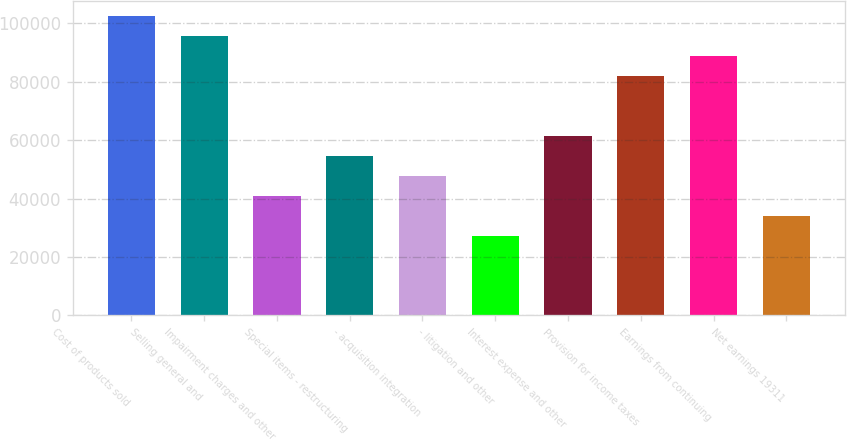<chart> <loc_0><loc_0><loc_500><loc_500><bar_chart><fcel>Cost of products sold<fcel>Selling general and<fcel>Impairment charges and other<fcel>Special items - restructuring<fcel>- acquisition integration<fcel>- litigation and other<fcel>Interest expense and other<fcel>Provision for income taxes<fcel>Earnings from continuing<fcel>Net earnings 19311<nl><fcel>102309<fcel>95488.9<fcel>40923.8<fcel>54565.1<fcel>47744.4<fcel>27282.6<fcel>61385.7<fcel>81847.6<fcel>88668.2<fcel>34103.2<nl></chart> 